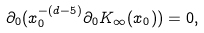Convert formula to latex. <formula><loc_0><loc_0><loc_500><loc_500>\partial _ { 0 } ( x _ { 0 } ^ { - ( d - 5 ) } \partial _ { 0 } K _ { \infty } ( x _ { 0 } ) ) = 0 ,</formula> 